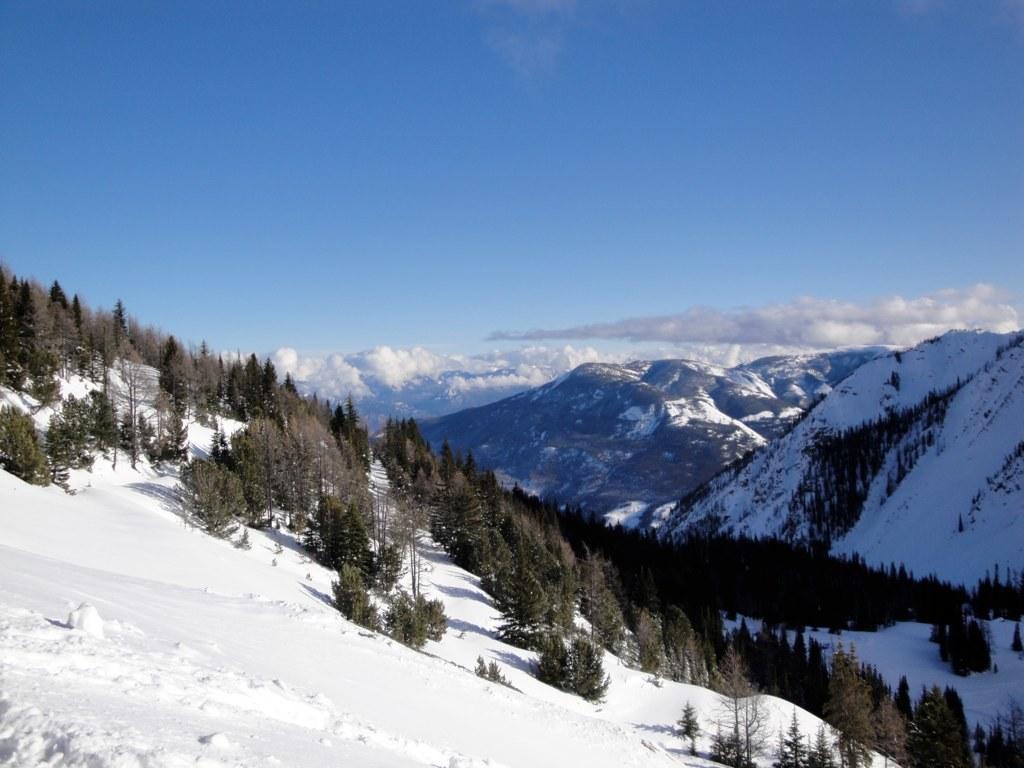Describe this image in one or two sentences. There are trees, hills and sky with clouds. On the ground there is snow. 